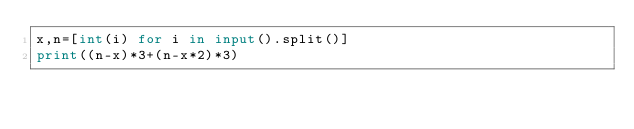<code> <loc_0><loc_0><loc_500><loc_500><_Python_>x,n=[int(i) for i in input().split()]
print((n-x)*3+(n-x*2)*3)</code> 